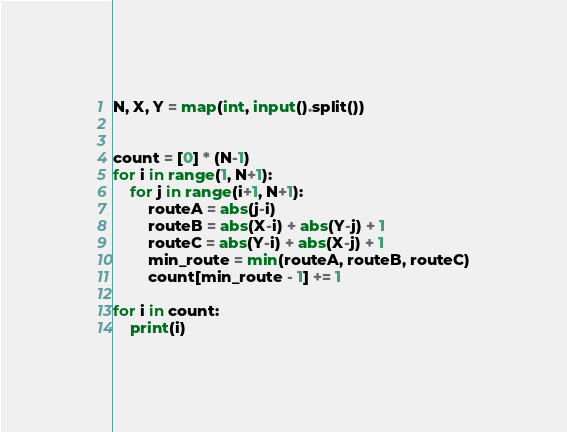<code> <loc_0><loc_0><loc_500><loc_500><_Python_>N, X, Y = map(int, input().split())


count = [0] * (N-1)
for i in range(1, N+1):
    for j in range(i+1, N+1):
        routeA = abs(j-i)
        routeB = abs(X-i) + abs(Y-j) + 1
        routeC = abs(Y-i) + abs(X-j) + 1
        min_route = min(routeA, routeB, routeC)
        count[min_route - 1] += 1

for i in count:
    print(i)</code> 